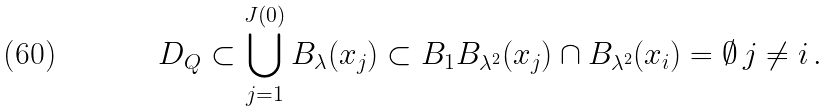Convert formula to latex. <formula><loc_0><loc_0><loc_500><loc_500>D _ { Q } \subset \bigcup _ { j = 1 } ^ { J ( 0 ) } B _ { \lambda } ( x _ { j } ) \subset B _ { 1 } B _ { \lambda ^ { 2 } } ( x _ { j } ) \cap B _ { \lambda ^ { 2 } } ( x _ { i } ) = \emptyset \, j \neq i \, .</formula> 